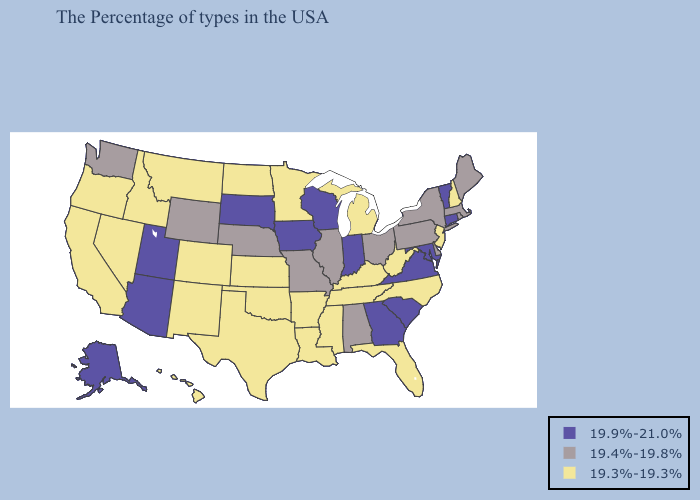Does Mississippi have the same value as Washington?
Short answer required. No. Does Alabama have a lower value than Iowa?
Be succinct. Yes. Does the map have missing data?
Be succinct. No. Does North Dakota have a higher value than Wisconsin?
Concise answer only. No. Does Texas have the lowest value in the USA?
Quick response, please. Yes. What is the highest value in the West ?
Concise answer only. 19.9%-21.0%. Name the states that have a value in the range 19.4%-19.8%?
Keep it brief. Maine, Massachusetts, Rhode Island, New York, Delaware, Pennsylvania, Ohio, Alabama, Illinois, Missouri, Nebraska, Wyoming, Washington. Name the states that have a value in the range 19.9%-21.0%?
Answer briefly. Vermont, Connecticut, Maryland, Virginia, South Carolina, Georgia, Indiana, Wisconsin, Iowa, South Dakota, Utah, Arizona, Alaska. Is the legend a continuous bar?
Quick response, please. No. Does Kansas have the same value as Minnesota?
Write a very short answer. Yes. What is the highest value in the USA?
Be succinct. 19.9%-21.0%. Which states have the lowest value in the South?
Keep it brief. North Carolina, West Virginia, Florida, Kentucky, Tennessee, Mississippi, Louisiana, Arkansas, Oklahoma, Texas. What is the value of Washington?
Short answer required. 19.4%-19.8%. Does Washington have a lower value than Arizona?
Give a very brief answer. Yes. 